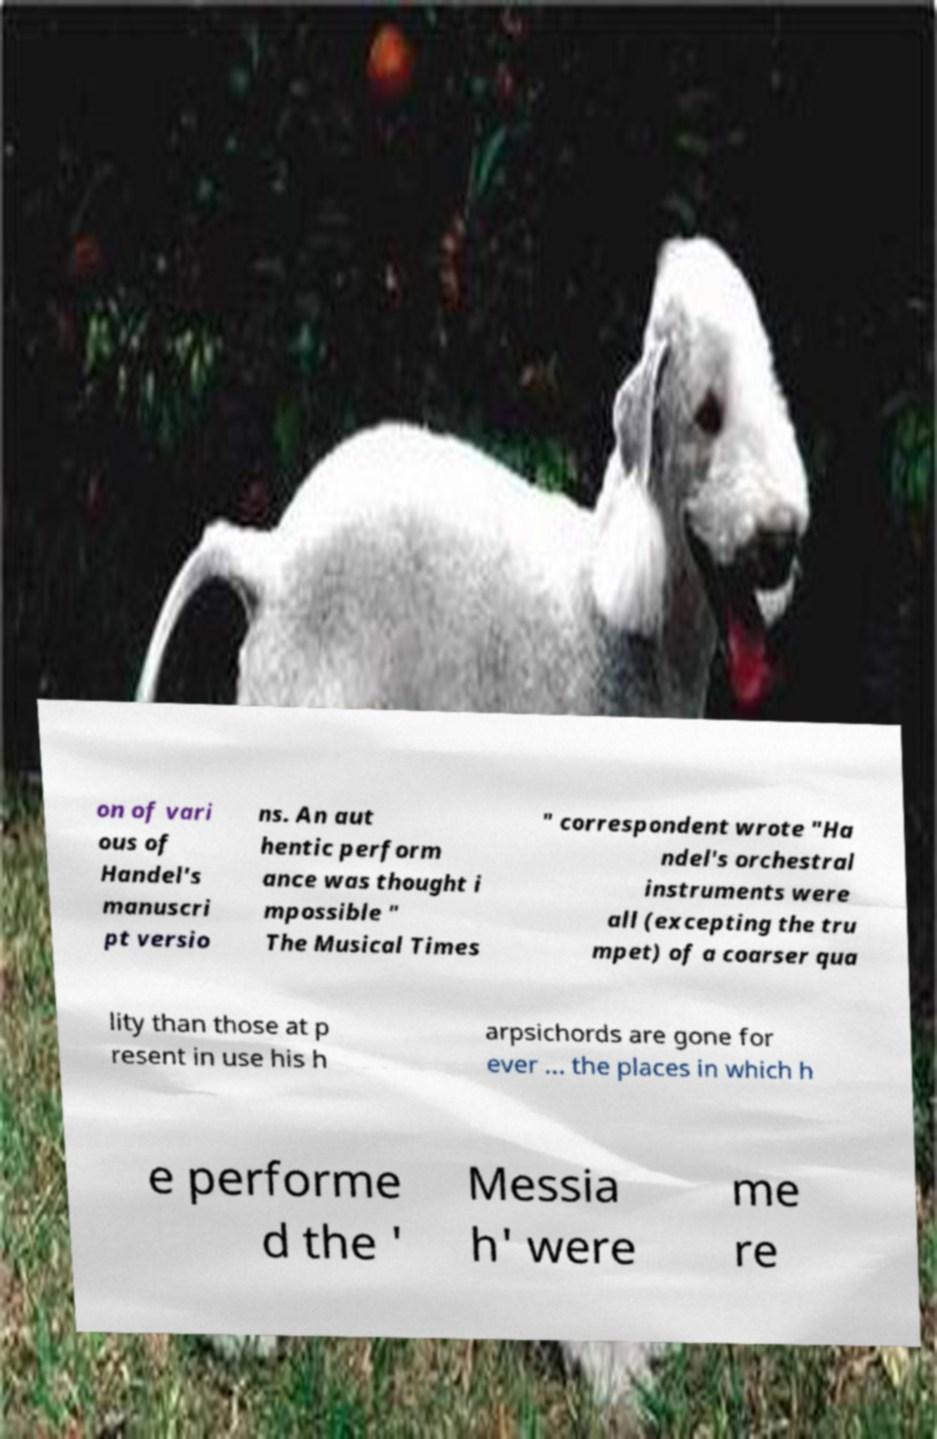I need the written content from this picture converted into text. Can you do that? on of vari ous of Handel's manuscri pt versio ns. An aut hentic perform ance was thought i mpossible " The Musical Times " correspondent wrote "Ha ndel's orchestral instruments were all (excepting the tru mpet) of a coarser qua lity than those at p resent in use his h arpsichords are gone for ever ... the places in which h e performe d the ' Messia h' were me re 